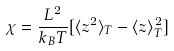Convert formula to latex. <formula><loc_0><loc_0><loc_500><loc_500>\chi = \frac { L ^ { 2 } } { k _ { B } T } [ \langle z ^ { 2 } \rangle _ { T } - \langle z \rangle ^ { 2 } _ { T } ]</formula> 